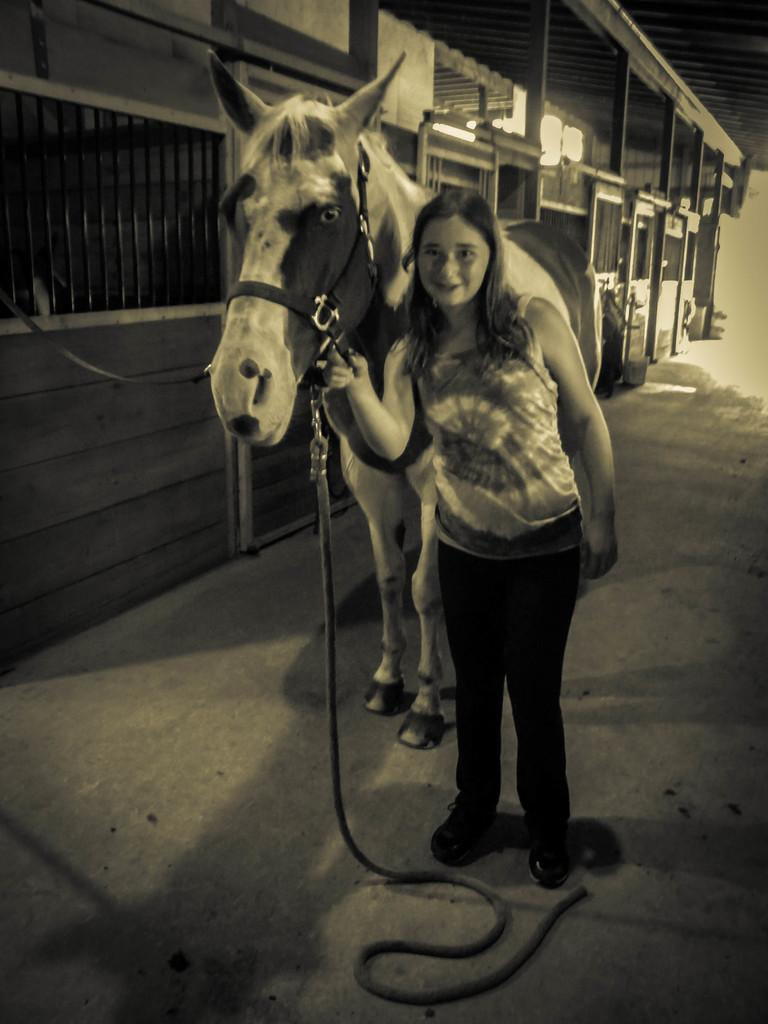What is the color scheme of the image? The image is black and white. Who is present in the image? There is a woman in the image. What is the woman holding? The woman is holding a belt. What can be seen behind the woman? There is a horse behind the woman. What type of structure is visible in the background? The background of the image includes a shed. Can you see any sea creatures in the image? There are no sea creatures present in the image, as it is a black and white image featuring a woman, a horse, and a shed. 